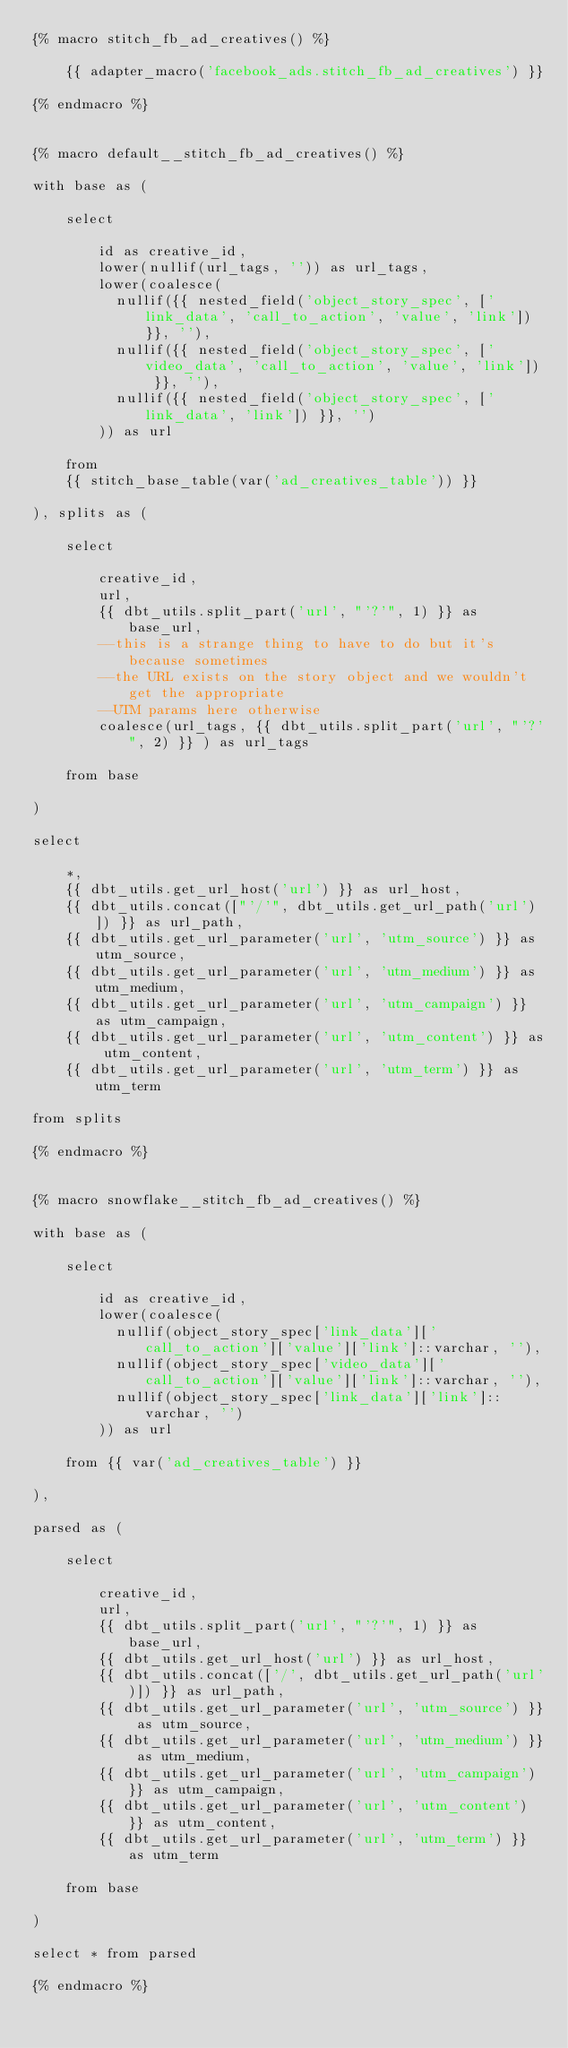<code> <loc_0><loc_0><loc_500><loc_500><_SQL_>{% macro stitch_fb_ad_creatives() %}

    {{ adapter_macro('facebook_ads.stitch_fb_ad_creatives') }}

{% endmacro %}


{% macro default__stitch_fb_ad_creatives() %}

with base as (

    select
    
        id as creative_id,
        lower(nullif(url_tags, '')) as url_tags,
        lower(coalesce(
          nullif({{ nested_field('object_story_spec', ['link_data', 'call_to_action', 'value', 'link']) }}, ''),
          nullif({{ nested_field('object_story_spec', ['video_data', 'call_to_action', 'value', 'link']) }}, ''),
          nullif({{ nested_field('object_story_spec', ['link_data', 'link']) }}, '')
        )) as url
    
    from
    {{ stitch_base_table(var('ad_creatives_table')) }}

), splits as (

    select
    
        creative_id,
        url,
        {{ dbt_utils.split_part('url', "'?'", 1) }} as base_url,
        --this is a strange thing to have to do but it's because sometimes 
        --the URL exists on the story object and we wouldn't get the appropriate 
        --UTM params here otherwise
        coalesce(url_tags, {{ dbt_utils.split_part('url', "'?'", 2) }} ) as url_tags
    
    from base

)

select

    *,
    {{ dbt_utils.get_url_host('url') }} as url_host,
    {{ dbt_utils.concat(["'/'", dbt_utils.get_url_path('url')]) }} as url_path,
    {{ dbt_utils.get_url_parameter('url', 'utm_source') }} as utm_source,
    {{ dbt_utils.get_url_parameter('url', 'utm_medium') }} as utm_medium,
    {{ dbt_utils.get_url_parameter('url', 'utm_campaign') }} as utm_campaign,
    {{ dbt_utils.get_url_parameter('url', 'utm_content') }} as utm_content,
    {{ dbt_utils.get_url_parameter('url', 'utm_term') }} as utm_term
    
from splits

{% endmacro %}


{% macro snowflake__stitch_fb_ad_creatives() %}

with base as (

    select

        id as creative_id,
        lower(coalesce(
          nullif(object_story_spec['link_data']['call_to_action']['value']['link']::varchar, ''),
          nullif(object_story_spec['video_data']['call_to_action']['value']['link']::varchar, ''),
          nullif(object_story_spec['link_data']['link']::varchar, '')
        )) as url

    from {{ var('ad_creatives_table') }}

),

parsed as (

    select
    
        creative_id,
        url,
        {{ dbt_utils.split_part('url', "'?'", 1) }} as base_url,
        {{ dbt_utils.get_url_host('url') }} as url_host,
        {{ dbt_utils.concat(['/', dbt_utils.get_url_path('url')]) }} as url_path,
        {{ dbt_utils.get_url_parameter('url', 'utm_source') }} as utm_source,
        {{ dbt_utils.get_url_parameter('url', 'utm_medium') }} as utm_medium,
        {{ dbt_utils.get_url_parameter('url', 'utm_campaign') }} as utm_campaign,
        {{ dbt_utils.get_url_parameter('url', 'utm_content') }} as utm_content,
        {{ dbt_utils.get_url_parameter('url', 'utm_term') }} as utm_term
        
    from base 

)

select * from parsed

{% endmacro %}</code> 